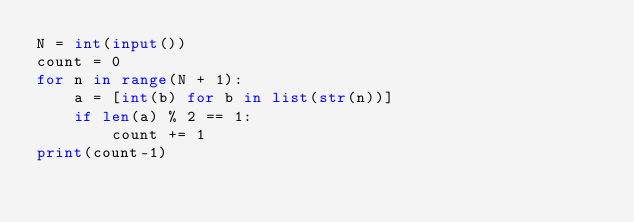<code> <loc_0><loc_0><loc_500><loc_500><_Python_>N = int(input())
count = 0
for n in range(N + 1):
    a = [int(b) for b in list(str(n))]
    if len(a) % 2 == 1:
        count += 1
print(count-1)

</code> 